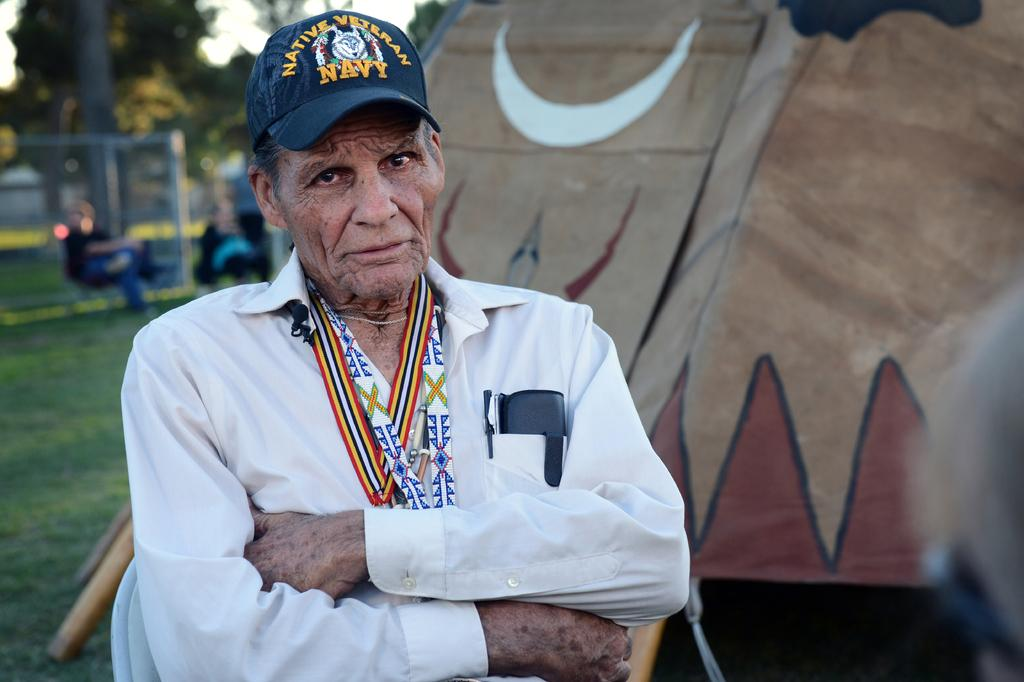<image>
Provide a brief description of the given image. the old white shirted man standing with folding hands who wears the blue color cap printed as native veteran navy 